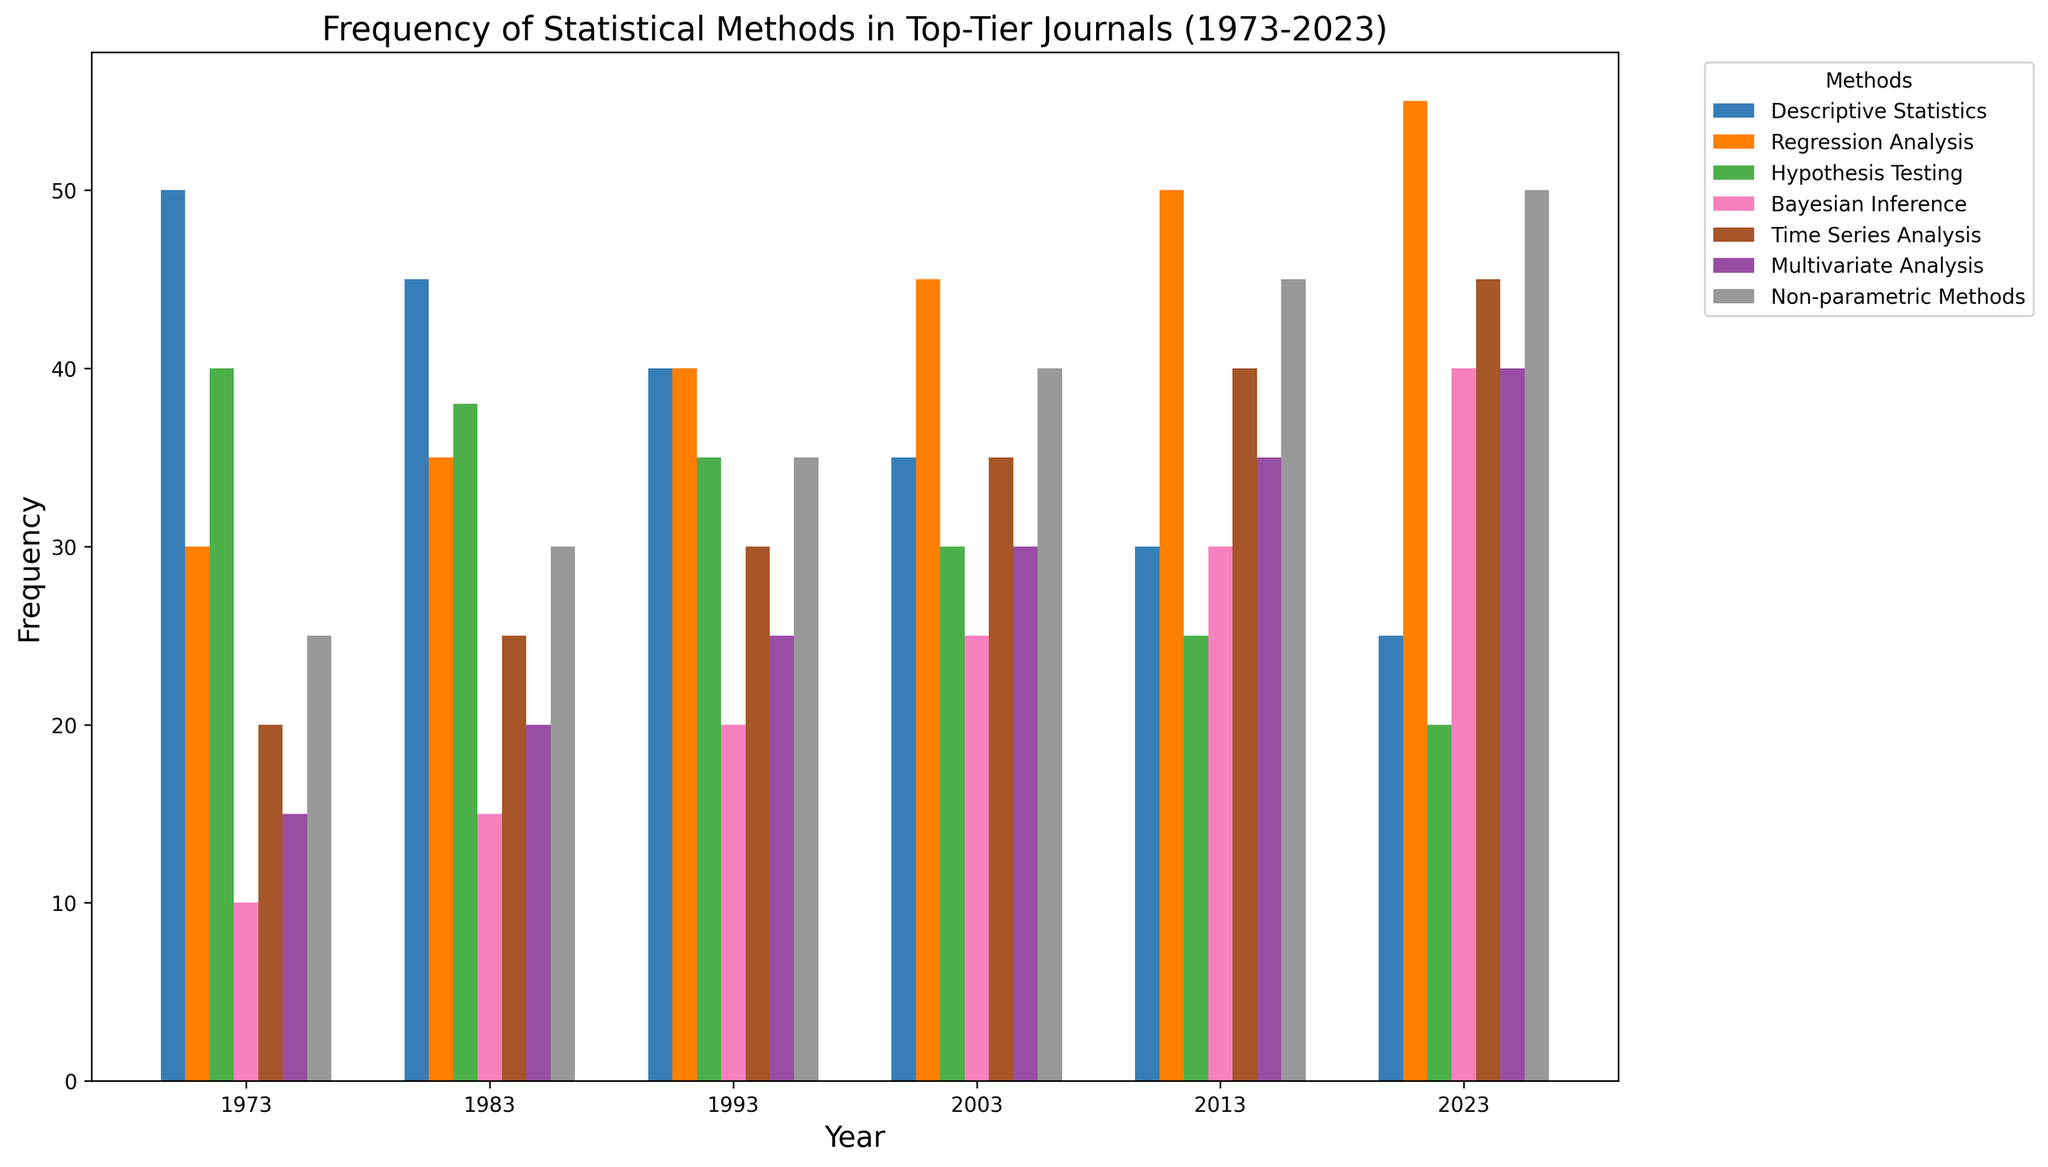What is the most frequent statistical method used in 2023? Looking at the 2023 bar group, the longest bar corresponds to Regression Analysis with a frequency of 55.
Answer: Regression Analysis How has the frequency of Bayesian Inference changed from 1973 to 2023? In 1973, the frequency of Bayesian Inference was 10. In 2023, it increased to 40. So, the change is 40 - 10 = 30.
Answer: Increased by 30 Which year had the highest frequency of Descriptive Statistics? Examining the bars for Descriptive Statistics across all years, the highest bar is in 1973 with a frequency of 50.
Answer: 1973 Compare the frequencies of Hypothesis Testing in 1973 and 2013. Which year had a higher frequency, and by how much? Hypothesis Testing had a frequency of 40 in 1973 and 25 in 2013. Thus, 1973 had a higher frequency by 40 - 25 = 15.
Answer: 1973 by 15 What is the combined frequency of Time Series Analysis and Multivariate Analysis in 2023? Time Series Analysis in 2023 has a frequency of 45, and Multivariate Analysis has 40. Summing these up: 45 + 40 = 85.
Answer: 85 Which statistical method had the least frequency in 2003? The shortest bar in 2003 corresponds to Hypothesis Testing with a frequency of 30.
Answer: Hypothesis Testing What is the average frequency of Regression Analysis over the years considered? The frequencies are 30, 35, 40, 45, 50, and 55. Summing these: 30 + 35 + 40 + 45 + 50 + 55 = 255. Average = 255 / 6 = 42.5.
Answer: 42.5 Which statistical method showed the most consistent frequency across the depicted years? By observing the bars for stability in height, Descriptive Statistics shows a consistent decreasing trend but similar bar lengths are seen for Non-parametric Methods, increasing steadily each decade, suggesting it is the most consistent overall.
Answer: Non-parametric Methods 